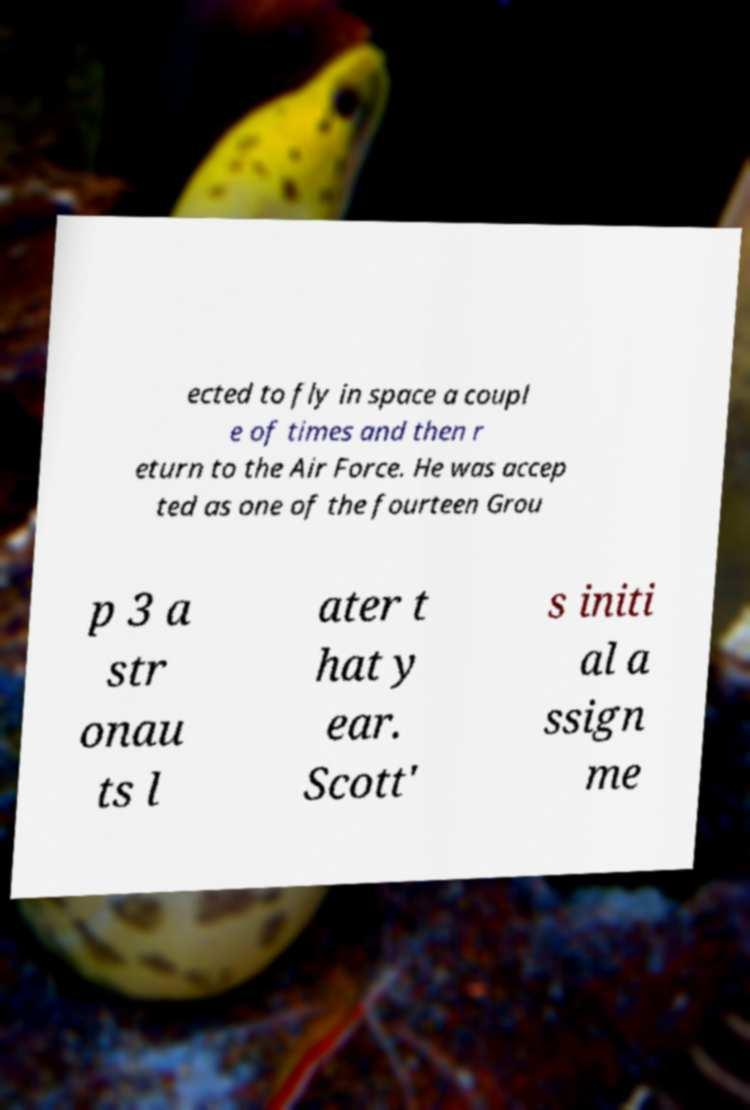Please identify and transcribe the text found in this image. ected to fly in space a coupl e of times and then r eturn to the Air Force. He was accep ted as one of the fourteen Grou p 3 a str onau ts l ater t hat y ear. Scott' s initi al a ssign me 